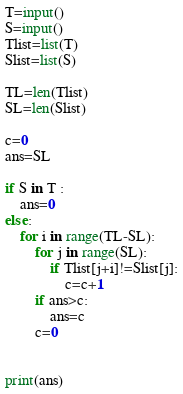Convert code to text. <code><loc_0><loc_0><loc_500><loc_500><_Python_>
T=input()
S=input()
Tlist=list(T)
Slist=list(S)

TL=len(Tlist)
SL=len(Slist)

c=0
ans=SL

if S in T :
    ans=0
else:
    for i in range(TL-SL):
        for j in range(SL):
            if Tlist[j+i]!=Slist[j]:
                c=c+1
        if ans>c:
            ans=c
        c=0
            
        
print(ans)
</code> 